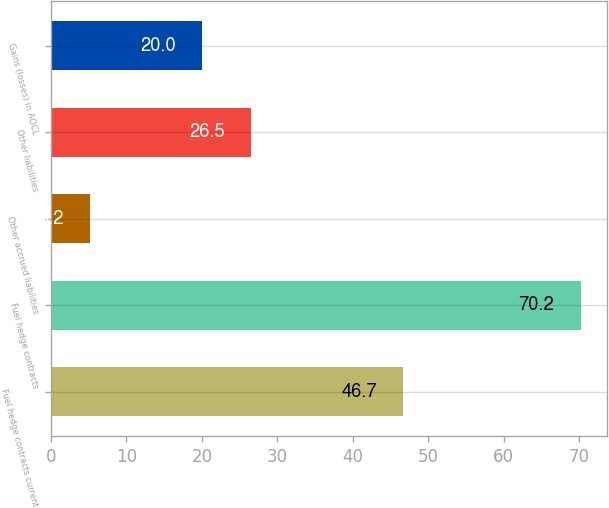<chart> <loc_0><loc_0><loc_500><loc_500><bar_chart><fcel>Fuel hedge contracts current<fcel>Fuel hedge contracts<fcel>Other accrued liabilities<fcel>Other liabilities<fcel>Gains (losses) in AOCL<nl><fcel>46.7<fcel>70.2<fcel>5.2<fcel>26.5<fcel>20<nl></chart> 